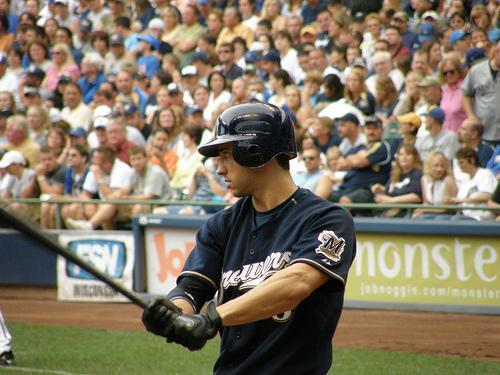How many people are in the photo?
Give a very brief answer. 3. 